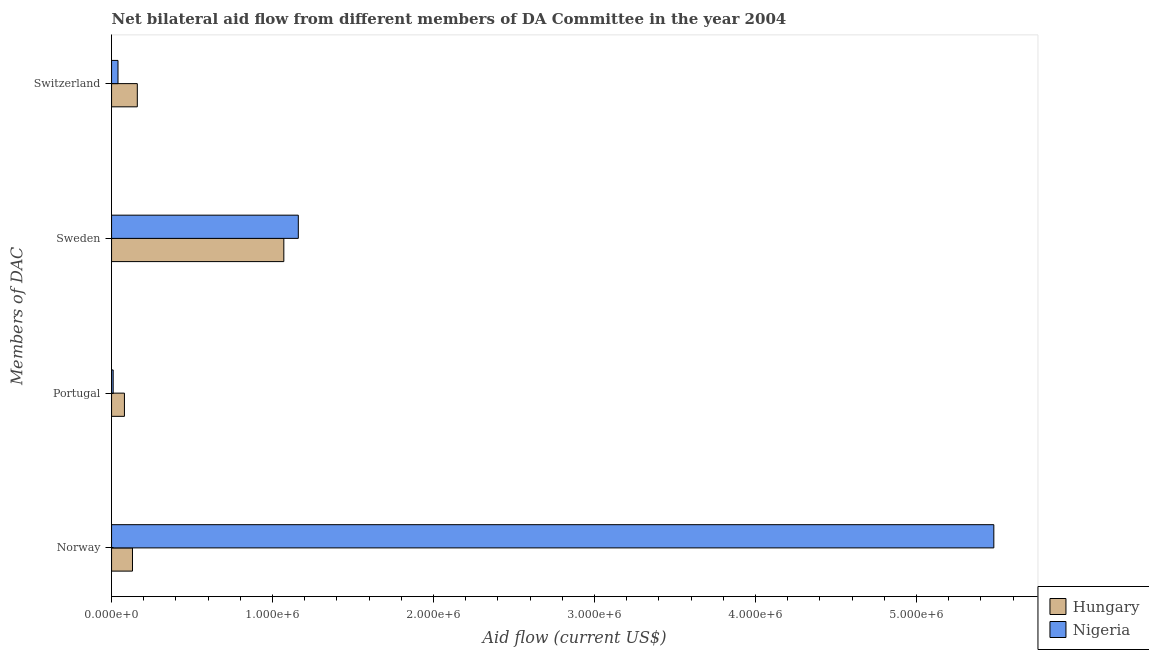How many different coloured bars are there?
Provide a succinct answer. 2. How many groups of bars are there?
Your response must be concise. 4. Are the number of bars per tick equal to the number of legend labels?
Make the answer very short. Yes. Are the number of bars on each tick of the Y-axis equal?
Provide a succinct answer. Yes. How many bars are there on the 1st tick from the bottom?
Give a very brief answer. 2. What is the label of the 1st group of bars from the top?
Provide a short and direct response. Switzerland. What is the amount of aid given by sweden in Nigeria?
Your answer should be compact. 1.16e+06. Across all countries, what is the maximum amount of aid given by sweden?
Your response must be concise. 1.16e+06. Across all countries, what is the minimum amount of aid given by switzerland?
Make the answer very short. 4.00e+04. In which country was the amount of aid given by norway maximum?
Offer a terse response. Nigeria. In which country was the amount of aid given by portugal minimum?
Your response must be concise. Nigeria. What is the total amount of aid given by portugal in the graph?
Your response must be concise. 9.00e+04. What is the difference between the amount of aid given by sweden in Nigeria and that in Hungary?
Ensure brevity in your answer.  9.00e+04. What is the difference between the amount of aid given by switzerland in Nigeria and the amount of aid given by portugal in Hungary?
Give a very brief answer. -4.00e+04. What is the average amount of aid given by sweden per country?
Provide a succinct answer. 1.12e+06. What is the difference between the amount of aid given by sweden and amount of aid given by norway in Hungary?
Offer a very short reply. 9.40e+05. Is the difference between the amount of aid given by norway in Hungary and Nigeria greater than the difference between the amount of aid given by sweden in Hungary and Nigeria?
Offer a terse response. No. What is the difference between the highest and the second highest amount of aid given by portugal?
Your answer should be compact. 7.00e+04. What is the difference between the highest and the lowest amount of aid given by sweden?
Ensure brevity in your answer.  9.00e+04. Is the sum of the amount of aid given by portugal in Nigeria and Hungary greater than the maximum amount of aid given by norway across all countries?
Keep it short and to the point. No. What does the 1st bar from the top in Switzerland represents?
Give a very brief answer. Nigeria. What does the 2nd bar from the bottom in Norway represents?
Your answer should be compact. Nigeria. Is it the case that in every country, the sum of the amount of aid given by norway and amount of aid given by portugal is greater than the amount of aid given by sweden?
Provide a succinct answer. No. How many bars are there?
Offer a terse response. 8. How many countries are there in the graph?
Make the answer very short. 2. What is the difference between two consecutive major ticks on the X-axis?
Ensure brevity in your answer.  1.00e+06. Does the graph contain grids?
Provide a short and direct response. No. How many legend labels are there?
Provide a short and direct response. 2. How are the legend labels stacked?
Ensure brevity in your answer.  Vertical. What is the title of the graph?
Your response must be concise. Net bilateral aid flow from different members of DA Committee in the year 2004. What is the label or title of the Y-axis?
Your answer should be very brief. Members of DAC. What is the Aid flow (current US$) of Nigeria in Norway?
Give a very brief answer. 5.48e+06. What is the Aid flow (current US$) of Nigeria in Portugal?
Your response must be concise. 10000. What is the Aid flow (current US$) of Hungary in Sweden?
Keep it short and to the point. 1.07e+06. What is the Aid flow (current US$) of Nigeria in Sweden?
Your answer should be very brief. 1.16e+06. What is the Aid flow (current US$) in Hungary in Switzerland?
Ensure brevity in your answer.  1.60e+05. Across all Members of DAC, what is the maximum Aid flow (current US$) of Hungary?
Offer a terse response. 1.07e+06. Across all Members of DAC, what is the maximum Aid flow (current US$) of Nigeria?
Provide a succinct answer. 5.48e+06. Across all Members of DAC, what is the minimum Aid flow (current US$) in Nigeria?
Your answer should be compact. 10000. What is the total Aid flow (current US$) of Hungary in the graph?
Keep it short and to the point. 1.44e+06. What is the total Aid flow (current US$) of Nigeria in the graph?
Ensure brevity in your answer.  6.69e+06. What is the difference between the Aid flow (current US$) in Nigeria in Norway and that in Portugal?
Make the answer very short. 5.47e+06. What is the difference between the Aid flow (current US$) in Hungary in Norway and that in Sweden?
Offer a very short reply. -9.40e+05. What is the difference between the Aid flow (current US$) in Nigeria in Norway and that in Sweden?
Keep it short and to the point. 4.32e+06. What is the difference between the Aid flow (current US$) of Hungary in Norway and that in Switzerland?
Offer a terse response. -3.00e+04. What is the difference between the Aid flow (current US$) of Nigeria in Norway and that in Switzerland?
Provide a short and direct response. 5.44e+06. What is the difference between the Aid flow (current US$) of Hungary in Portugal and that in Sweden?
Your answer should be compact. -9.90e+05. What is the difference between the Aid flow (current US$) of Nigeria in Portugal and that in Sweden?
Your response must be concise. -1.15e+06. What is the difference between the Aid flow (current US$) in Hungary in Portugal and that in Switzerland?
Offer a terse response. -8.00e+04. What is the difference between the Aid flow (current US$) in Nigeria in Portugal and that in Switzerland?
Ensure brevity in your answer.  -3.00e+04. What is the difference between the Aid flow (current US$) of Hungary in Sweden and that in Switzerland?
Provide a short and direct response. 9.10e+05. What is the difference between the Aid flow (current US$) in Nigeria in Sweden and that in Switzerland?
Your response must be concise. 1.12e+06. What is the difference between the Aid flow (current US$) of Hungary in Norway and the Aid flow (current US$) of Nigeria in Portugal?
Offer a terse response. 1.20e+05. What is the difference between the Aid flow (current US$) in Hungary in Norway and the Aid flow (current US$) in Nigeria in Sweden?
Keep it short and to the point. -1.03e+06. What is the difference between the Aid flow (current US$) of Hungary in Norway and the Aid flow (current US$) of Nigeria in Switzerland?
Your response must be concise. 9.00e+04. What is the difference between the Aid flow (current US$) in Hungary in Portugal and the Aid flow (current US$) in Nigeria in Sweden?
Ensure brevity in your answer.  -1.08e+06. What is the difference between the Aid flow (current US$) of Hungary in Sweden and the Aid flow (current US$) of Nigeria in Switzerland?
Give a very brief answer. 1.03e+06. What is the average Aid flow (current US$) in Hungary per Members of DAC?
Ensure brevity in your answer.  3.60e+05. What is the average Aid flow (current US$) of Nigeria per Members of DAC?
Your response must be concise. 1.67e+06. What is the difference between the Aid flow (current US$) in Hungary and Aid flow (current US$) in Nigeria in Norway?
Offer a terse response. -5.35e+06. What is the difference between the Aid flow (current US$) of Hungary and Aid flow (current US$) of Nigeria in Portugal?
Your answer should be compact. 7.00e+04. What is the difference between the Aid flow (current US$) in Hungary and Aid flow (current US$) in Nigeria in Sweden?
Offer a very short reply. -9.00e+04. What is the difference between the Aid flow (current US$) in Hungary and Aid flow (current US$) in Nigeria in Switzerland?
Your answer should be compact. 1.20e+05. What is the ratio of the Aid flow (current US$) of Hungary in Norway to that in Portugal?
Your answer should be very brief. 1.62. What is the ratio of the Aid flow (current US$) in Nigeria in Norway to that in Portugal?
Ensure brevity in your answer.  548. What is the ratio of the Aid flow (current US$) of Hungary in Norway to that in Sweden?
Ensure brevity in your answer.  0.12. What is the ratio of the Aid flow (current US$) in Nigeria in Norway to that in Sweden?
Offer a very short reply. 4.72. What is the ratio of the Aid flow (current US$) in Hungary in Norway to that in Switzerland?
Provide a succinct answer. 0.81. What is the ratio of the Aid flow (current US$) of Nigeria in Norway to that in Switzerland?
Provide a short and direct response. 137. What is the ratio of the Aid flow (current US$) in Hungary in Portugal to that in Sweden?
Make the answer very short. 0.07. What is the ratio of the Aid flow (current US$) of Nigeria in Portugal to that in Sweden?
Ensure brevity in your answer.  0.01. What is the ratio of the Aid flow (current US$) of Nigeria in Portugal to that in Switzerland?
Offer a very short reply. 0.25. What is the ratio of the Aid flow (current US$) in Hungary in Sweden to that in Switzerland?
Your answer should be compact. 6.69. What is the ratio of the Aid flow (current US$) of Nigeria in Sweden to that in Switzerland?
Provide a succinct answer. 29. What is the difference between the highest and the second highest Aid flow (current US$) of Hungary?
Ensure brevity in your answer.  9.10e+05. What is the difference between the highest and the second highest Aid flow (current US$) in Nigeria?
Your response must be concise. 4.32e+06. What is the difference between the highest and the lowest Aid flow (current US$) in Hungary?
Provide a short and direct response. 9.90e+05. What is the difference between the highest and the lowest Aid flow (current US$) in Nigeria?
Offer a very short reply. 5.47e+06. 